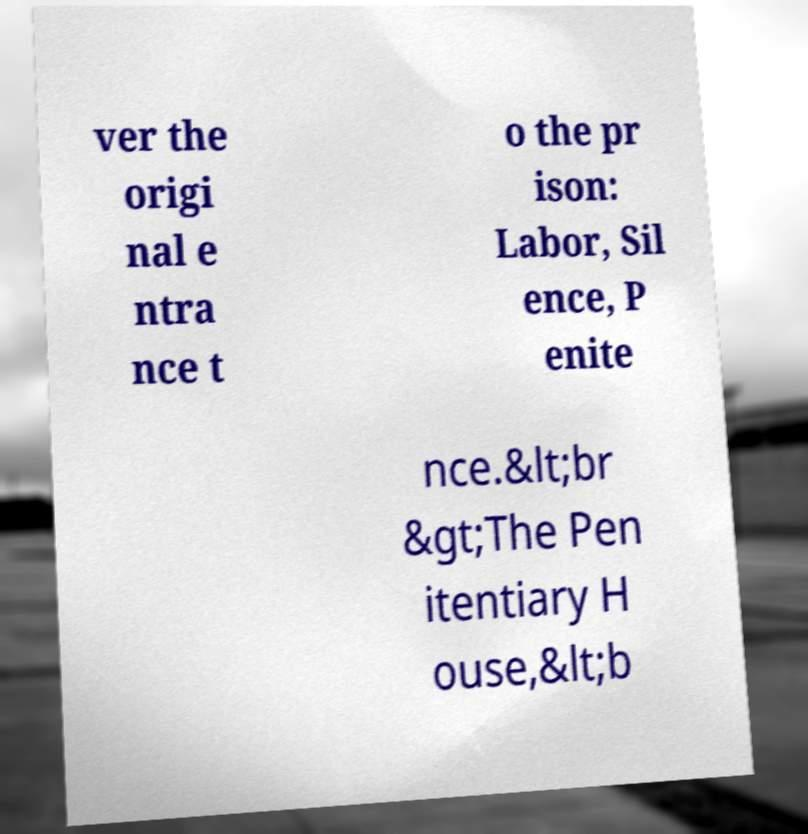Please identify and transcribe the text found in this image. ver the origi nal e ntra nce t o the pr ison: Labor, Sil ence, P enite nce.&lt;br &gt;The Pen itentiary H ouse,&lt;b 